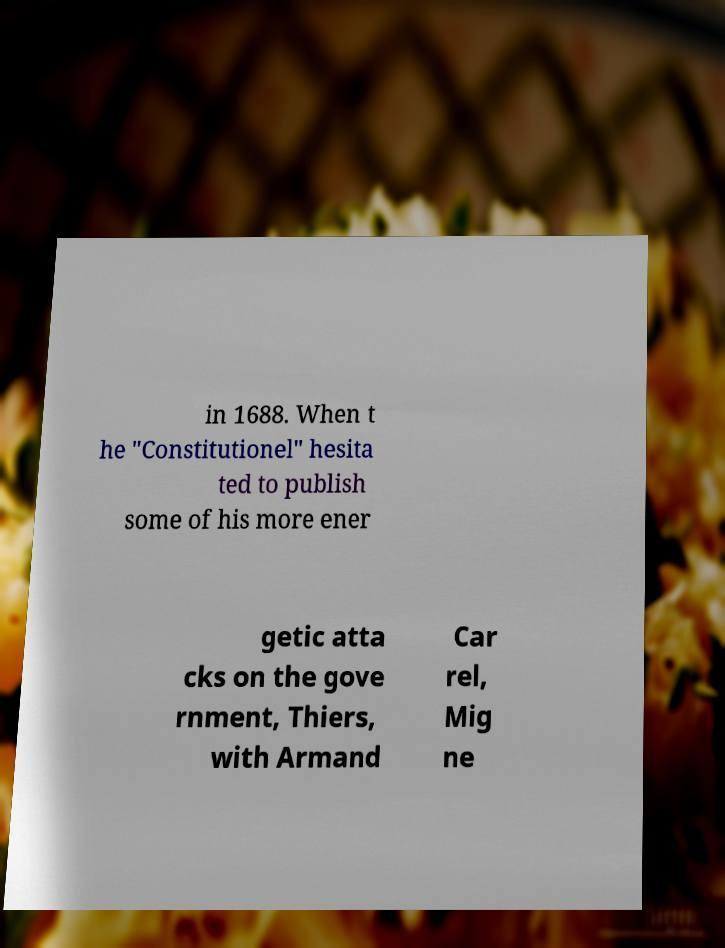Please read and relay the text visible in this image. What does it say? in 1688. When t he "Constitutionel" hesita ted to publish some of his more ener getic atta cks on the gove rnment, Thiers, with Armand Car rel, Mig ne 